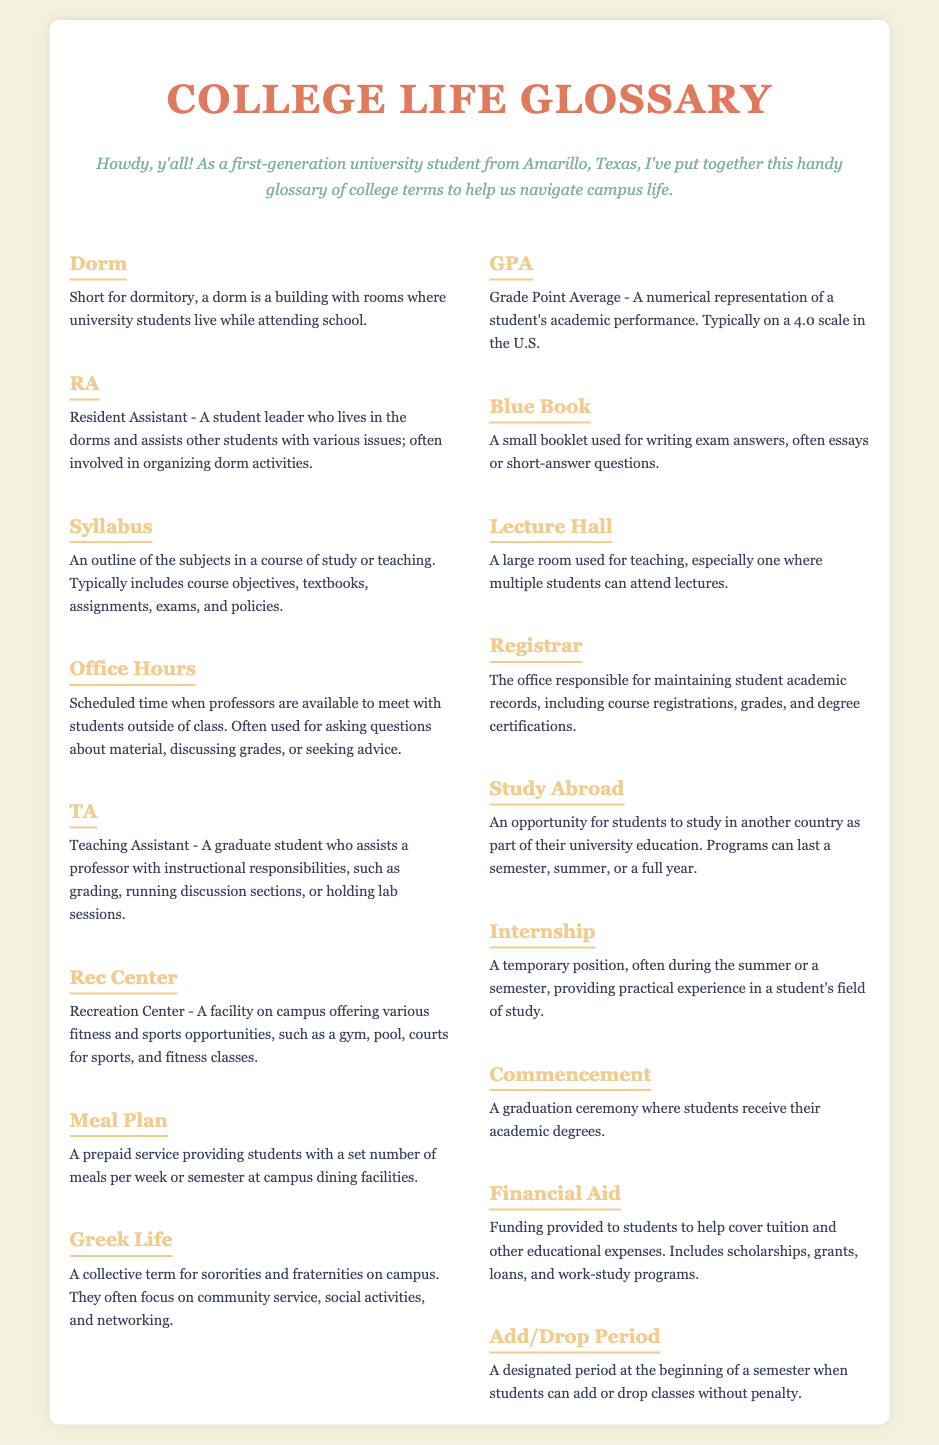What is short for dormitory? The term "Dorm" in the glossary is defined as short for dormitory, where university students live.
Answer: Dorm What does RA stand for? The glossary defines RA as Resident Assistant, a student leader in dorms.
Answer: Resident Assistant What is GPA? GPA is defined in the document as Grade Point Average, a numerical representation of academic performance.
Answer: Grade Point Average How long can a Study Abroad program last? The document states that a Study Abroad program can last a semester, summer, or a full year.
Answer: A semester, summer, or a full year What does Financial Aid include? The glossary lists scholarships, grants, loans, and work-study programs as types of Financial Aid.
Answer: Scholarships, grants, loans, and work-study programs What is the purpose of Office Hours? Office Hours are for meeting with professors outside of class for questions about material and grades.
Answer: Meeting with professors outside of class What is the role of a TA? A TA assists a professor with instructional responsibilities like grading and running discussions.
Answer: Assists a professor with instructional responsibilities What happens during the Commencement ceremony? Commencement is when students receive their academic degrees, according to the glossary.
Answer: Students receive their academic degrees When does the Add/Drop Period occur? The Add/Drop Period is designated at the beginning of a semester.
Answer: At the beginning of a semester 